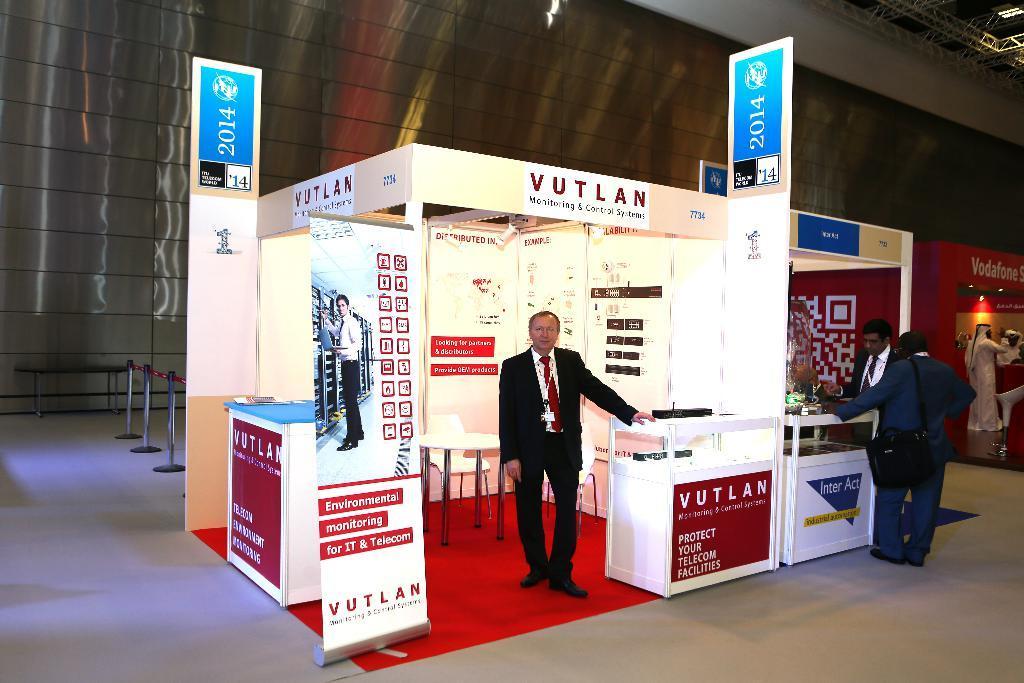In one or two sentences, can you explain what this image depicts? This image is taken indoors. At the bottom of the image there is a floor. In the middle of the image there is a stall and there are many boards with text on them. A man is standing on the floor and there are two chairs and a table. On the right side of the image there is a mannequin and two men are standing on the floor. In the background there is a wall. At the top of the image there is a roof. 